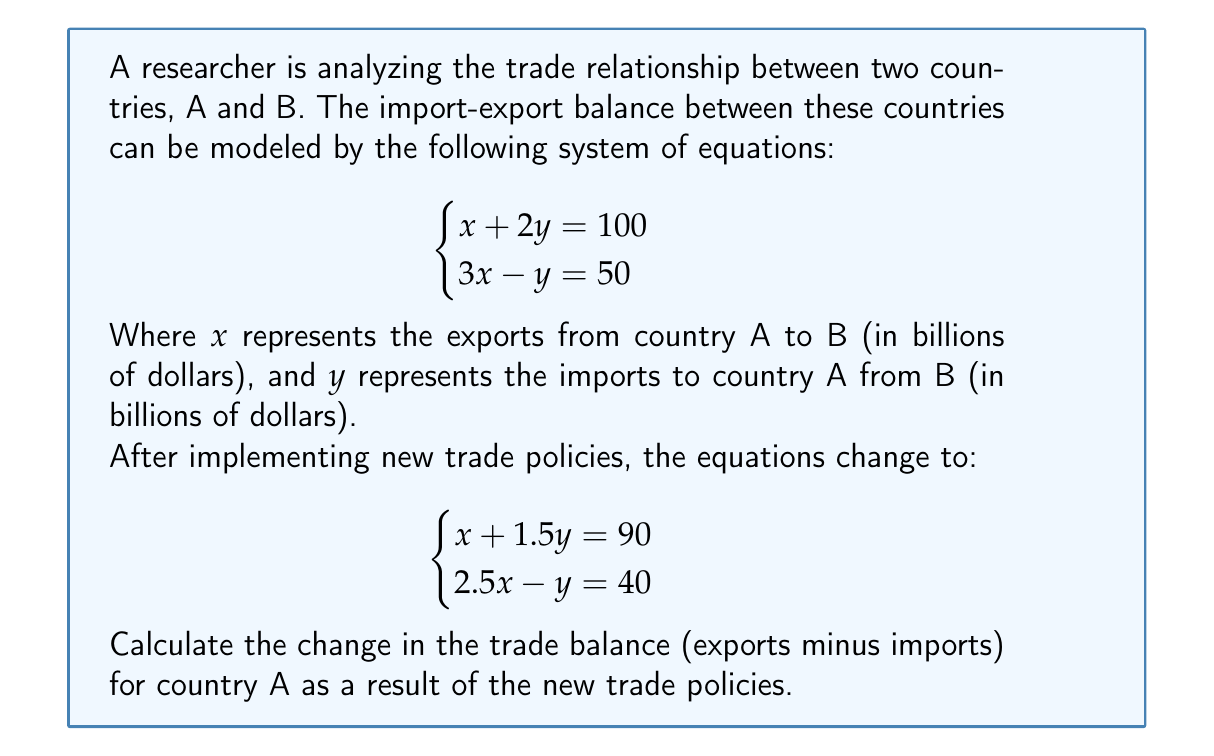Provide a solution to this math problem. To solve this problem, we need to follow these steps:

1. Solve the initial system of equations:
   $$\begin{cases}
   x + 2y = 100 \\
   3x - y = 50
   \end{cases}$$

   Multiply the first equation by 3 and the second by 2:
   $$\begin{cases}
   3x + 6y = 300 \\
   6x - 2y = 100
   \end{cases}$$

   Subtract the second equation from the first:
   $8y = 200$
   $y = 25$

   Substitute $y = 25$ into $x + 2y = 100$:
   $x + 2(25) = 100$
   $x + 50 = 100$
   $x = 50$

   Initial solution: $x = 50$, $y = 25$

2. Solve the new system of equations:
   $$\begin{cases}
   x + 1.5y = 90 \\
   2.5x - y = 40
   \end{cases}$$

   Multiply the first equation by 2.5 and the second by 1.5:
   $$\begin{cases}
   2.5x + 3.75y = 225 \\
   3.75x - 1.5y = 60
   \end{cases}$$

   Subtract the second equation from the first:
   $5.25y = 165$
   $y = 31.43$

   Substitute $y = 31.43$ into $x + 1.5y = 90$:
   $x + 1.5(31.43) = 90$
   $x + 47.14 = 90$
   $x = 42.86$

   New solution: $x = 42.86$, $y = 31.43$

3. Calculate the initial trade balance:
   Trade Balance = Exports - Imports = $x - y = 50 - 25 = 25$ billion dollars

4. Calculate the new trade balance:
   New Trade Balance = New Exports - New Imports = $42.86 - 31.43 = 11.43$ billion dollars

5. Calculate the change in trade balance:
   Change = New Trade Balance - Initial Trade Balance
   $= 11.43 - 25 = -13.57$ billion dollars
Answer: The change in the trade balance for country A as a result of the new trade policies is a decrease of $13.57 billion dollars. 